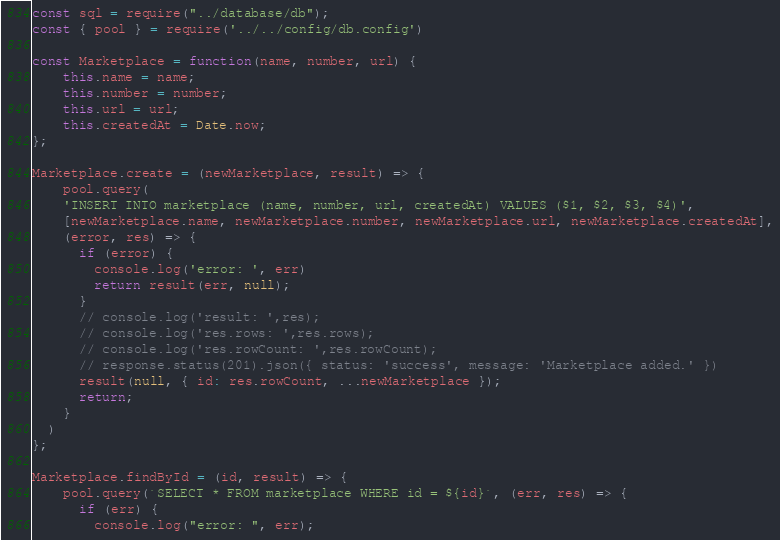<code> <loc_0><loc_0><loc_500><loc_500><_JavaScript_>const sql = require("../database/db");
const { pool } = require('../../config/db.config')

const Marketplace = function(name, number, url) {
    this.name = name;
    this.number = number;
    this.url = url;
    this.createdAt = Date.now;
};

Marketplace.create = (newMarketplace, result) => {
    pool.query(
    'INSERT INTO marketplace (name, number, url, createdAt) VALUES ($1, $2, $3, $4)',
    [newMarketplace.name, newMarketplace.number, newMarketplace.url, newMarketplace.createdAt],
    (error, res) => {
      if (error) {
        console.log('error: ', err)
        return result(err, null);
      }
      // console.log('result: ',res);
      // console.log('res.rows: ',res.rows);
      // console.log('res.rowCount: ',res.rowCount);
      // response.status(201).json({ status: 'success', message: 'Marketplace added.' })
      result(null, { id: res.rowCount, ...newMarketplace });
      return;
    }
  )
};

Marketplace.findById = (id, result) => {
    pool.query(`SELECT * FROM marketplace WHERE id = ${id}`, (err, res) => {
      if (err) {
        console.log("error: ", err);</code> 